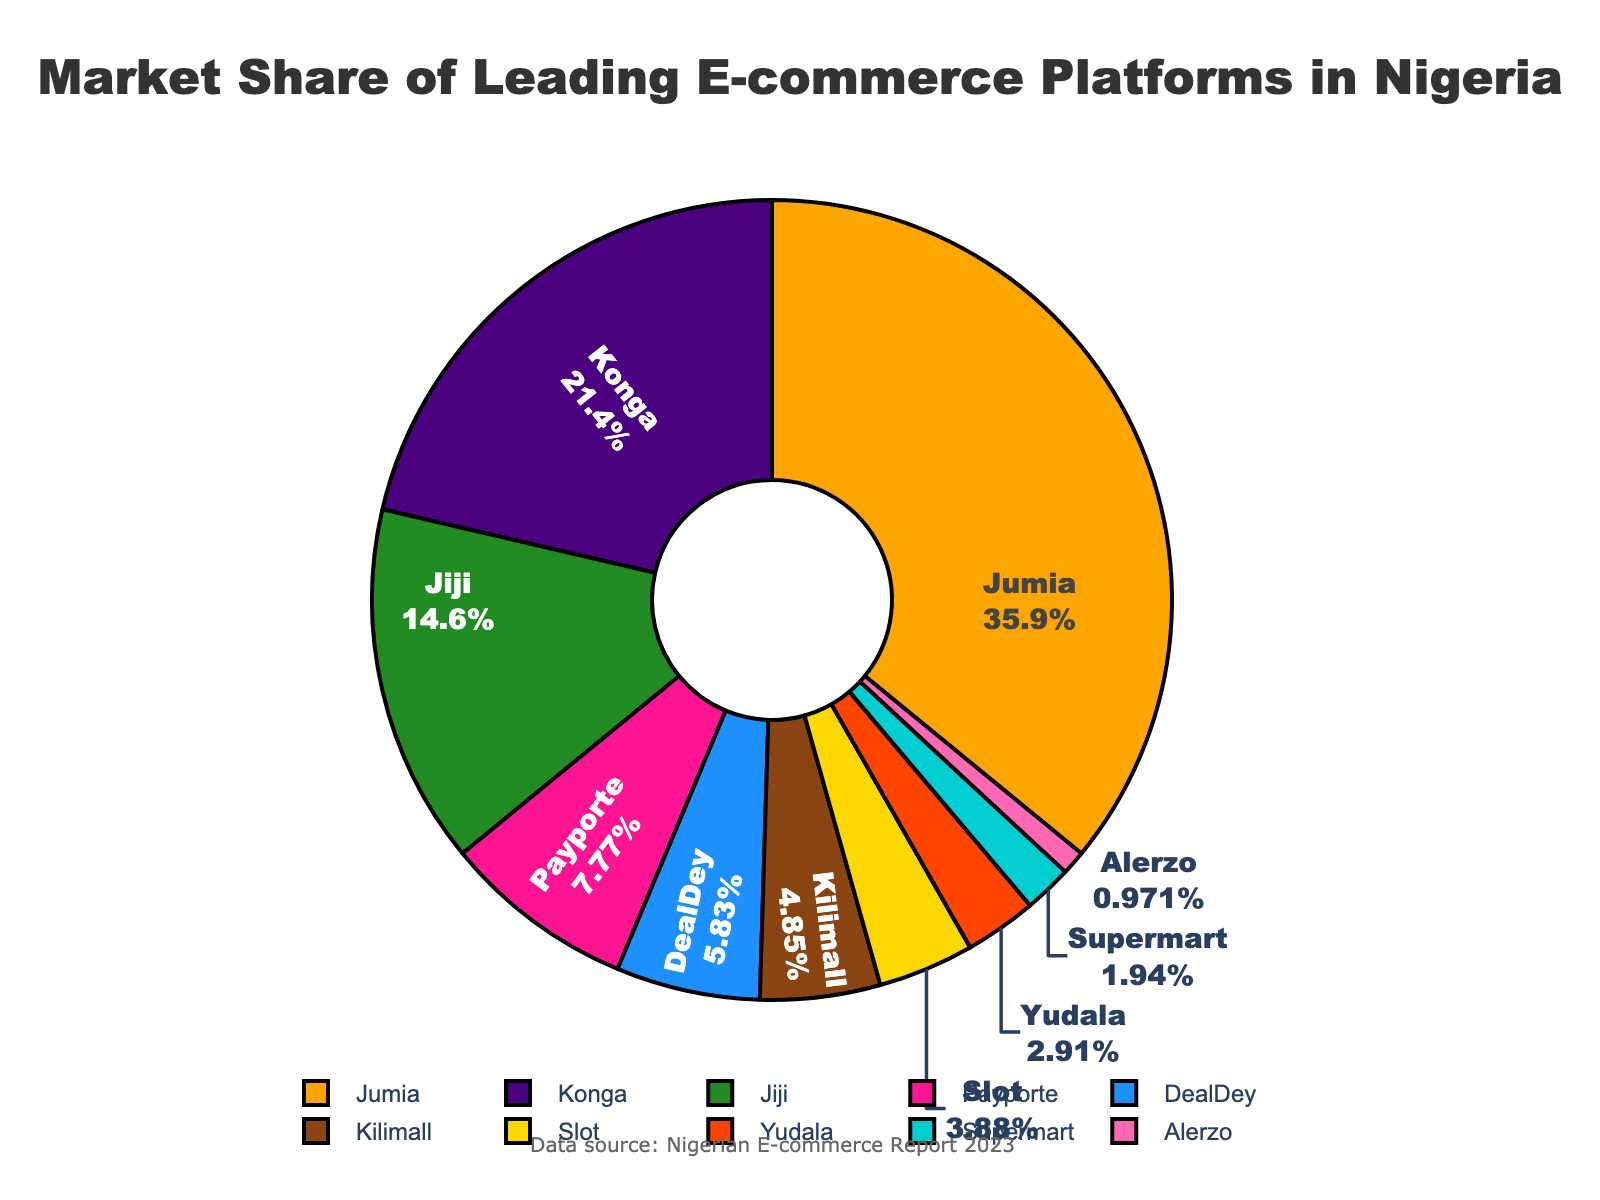what is the e-commerce platform with the largest market share? The figure shows the market share distribution of leading e-commerce platforms in Nigeria. By inspecting the slices of the pie, we can see that Jumia has the largest slice. According to the legend, Jumia holds 37% of the market share.
Answer: Jumia Which platform has a market share close to one-quarter of the total market? The closest platform to one-quarter (25%) of the total market share is Konga, which has a 22% market share, as indicated by the pie chart.
Answer: Konga What is the combined market share of Jiji and DealDey? The market share of Jiji is 15% and DealDey is 6%. Adding these together, we get 15% + 6% = 21%.
Answer: 21% Which e-commerce platforms hold less than 5% of the market share? By looking at the slices and their corresponding percentages in the pie chart, we see that the platforms with less than 5% market share are Slot (4%), Yudala (3%), Supermart (2%), and Alerzo (1%).
Answer: Slot, Yudala, Supermart, Alerzo How much greater is Jumia's market share compared to Payporte's? According to the pie chart, Jumia has a 37% market share while Payporte has an 8% market share. The difference is 37% - 8% = 29%.
Answer: 29% What is the visual representation color for Konga? The pie chart uses various colors to represent different platforms. Konga is represented by the second color in the palette which is indigo.
Answer: indigo Compare the combined market share of Payporte, DealDey, and Kilimall to that of Jiji. Which one is larger and by how much? Payporte has 8%, DealDey has 6%, and Kilimall has 5%. Their combined share is 8% + 6% + 5% = 19%. Jiji has a 15% market share. The combined share of Payporte, DealDey, and Kilimall is larger by 19% - 15% = 4%.
Answer: Payporte, DealDey, and Kilimall by 4% What fraction of the market share does the smallest platform hold? Alerzo holds the smallest market share at 1%, which can be expressed as 1/100 or 0.01 in fractional terms.
Answer: 1/100 Which e-commerce platform is represented by a cyan slice in the pie chart? The e-commerce platform represented by the cyan slice in the pie chart is Supermart.
Answer: Supermart What is the total market share held by the top three e-commerce platforms? The top three e-commerce platforms are Jumia (37%), Konga (22%), and Jiji (15%). Adding these together, we get 37% + 22% + 15% = 74%.
Answer: 74% 